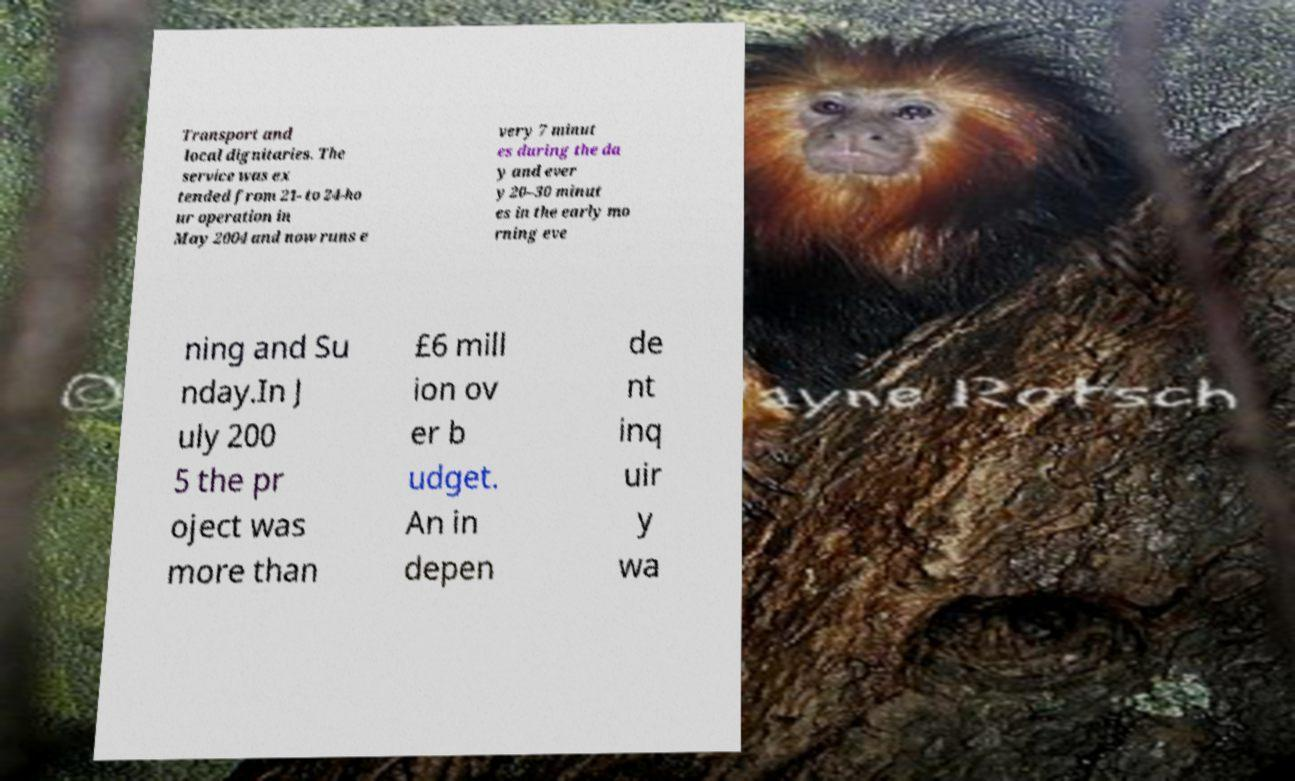Can you read and provide the text displayed in the image?This photo seems to have some interesting text. Can you extract and type it out for me? Transport and local dignitaries. The service was ex tended from 21- to 24-ho ur operation in May 2004 and now runs e very 7 minut es during the da y and ever y 20–30 minut es in the early mo rning eve ning and Su nday.In J uly 200 5 the pr oject was more than £6 mill ion ov er b udget. An in depen de nt inq uir y wa 